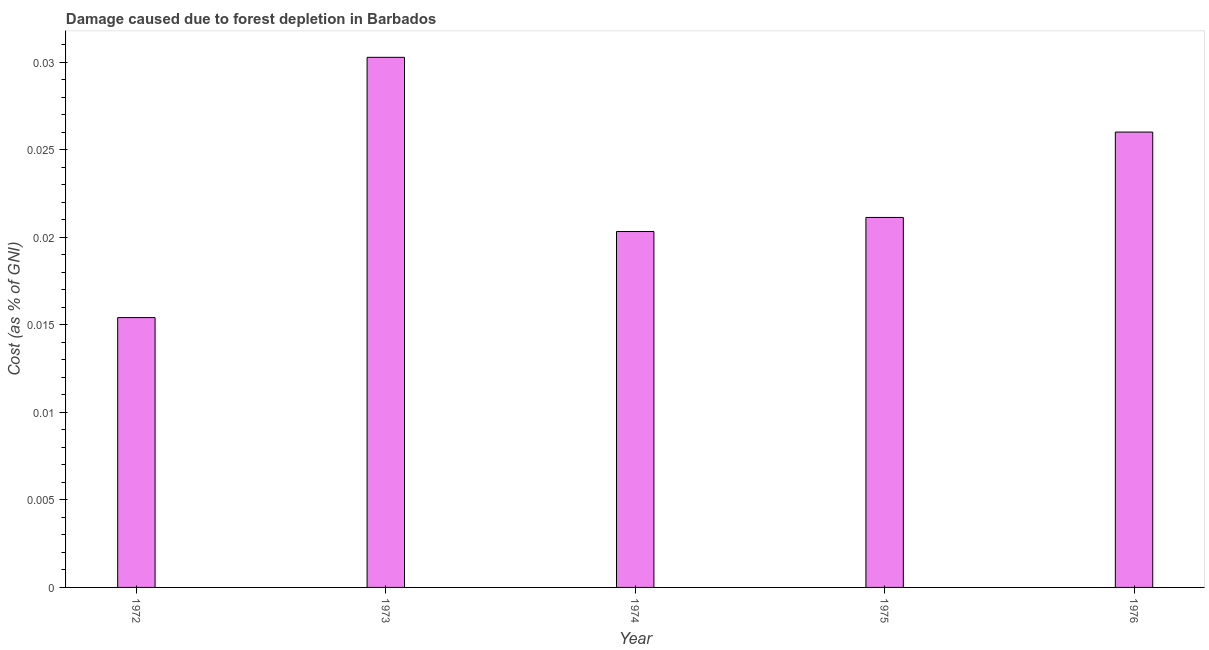Does the graph contain any zero values?
Provide a short and direct response. No. Does the graph contain grids?
Offer a terse response. No. What is the title of the graph?
Your answer should be very brief. Damage caused due to forest depletion in Barbados. What is the label or title of the X-axis?
Your answer should be compact. Year. What is the label or title of the Y-axis?
Provide a short and direct response. Cost (as % of GNI). What is the damage caused due to forest depletion in 1975?
Make the answer very short. 0.02. Across all years, what is the maximum damage caused due to forest depletion?
Provide a succinct answer. 0.03. Across all years, what is the minimum damage caused due to forest depletion?
Offer a terse response. 0.02. In which year was the damage caused due to forest depletion maximum?
Make the answer very short. 1973. What is the sum of the damage caused due to forest depletion?
Keep it short and to the point. 0.11. What is the difference between the damage caused due to forest depletion in 1973 and 1976?
Your answer should be compact. 0. What is the average damage caused due to forest depletion per year?
Your answer should be very brief. 0.02. What is the median damage caused due to forest depletion?
Your response must be concise. 0.02. Do a majority of the years between 1976 and 1973 (inclusive) have damage caused due to forest depletion greater than 0.008 %?
Give a very brief answer. Yes. What is the ratio of the damage caused due to forest depletion in 1973 to that in 1974?
Give a very brief answer. 1.49. Is the difference between the damage caused due to forest depletion in 1972 and 1973 greater than the difference between any two years?
Provide a succinct answer. Yes. What is the difference between the highest and the second highest damage caused due to forest depletion?
Keep it short and to the point. 0. Is the sum of the damage caused due to forest depletion in 1972 and 1974 greater than the maximum damage caused due to forest depletion across all years?
Offer a very short reply. Yes. In how many years, is the damage caused due to forest depletion greater than the average damage caused due to forest depletion taken over all years?
Your answer should be very brief. 2. How many bars are there?
Offer a very short reply. 5. Are all the bars in the graph horizontal?
Provide a succinct answer. No. What is the difference between two consecutive major ticks on the Y-axis?
Your answer should be compact. 0.01. What is the Cost (as % of GNI) of 1972?
Your answer should be very brief. 0.02. What is the Cost (as % of GNI) of 1973?
Your answer should be very brief. 0.03. What is the Cost (as % of GNI) in 1974?
Make the answer very short. 0.02. What is the Cost (as % of GNI) in 1975?
Your response must be concise. 0.02. What is the Cost (as % of GNI) in 1976?
Your response must be concise. 0.03. What is the difference between the Cost (as % of GNI) in 1972 and 1973?
Your answer should be compact. -0.01. What is the difference between the Cost (as % of GNI) in 1972 and 1974?
Your answer should be compact. -0. What is the difference between the Cost (as % of GNI) in 1972 and 1975?
Your answer should be very brief. -0.01. What is the difference between the Cost (as % of GNI) in 1972 and 1976?
Make the answer very short. -0.01. What is the difference between the Cost (as % of GNI) in 1973 and 1974?
Provide a short and direct response. 0.01. What is the difference between the Cost (as % of GNI) in 1973 and 1975?
Give a very brief answer. 0.01. What is the difference between the Cost (as % of GNI) in 1973 and 1976?
Your response must be concise. 0. What is the difference between the Cost (as % of GNI) in 1974 and 1975?
Offer a very short reply. -0. What is the difference between the Cost (as % of GNI) in 1974 and 1976?
Give a very brief answer. -0.01. What is the difference between the Cost (as % of GNI) in 1975 and 1976?
Your answer should be compact. -0. What is the ratio of the Cost (as % of GNI) in 1972 to that in 1973?
Give a very brief answer. 0.51. What is the ratio of the Cost (as % of GNI) in 1972 to that in 1974?
Give a very brief answer. 0.76. What is the ratio of the Cost (as % of GNI) in 1972 to that in 1975?
Your answer should be compact. 0.73. What is the ratio of the Cost (as % of GNI) in 1972 to that in 1976?
Offer a very short reply. 0.59. What is the ratio of the Cost (as % of GNI) in 1973 to that in 1974?
Provide a succinct answer. 1.49. What is the ratio of the Cost (as % of GNI) in 1973 to that in 1975?
Offer a terse response. 1.43. What is the ratio of the Cost (as % of GNI) in 1973 to that in 1976?
Provide a succinct answer. 1.16. What is the ratio of the Cost (as % of GNI) in 1974 to that in 1976?
Offer a very short reply. 0.78. What is the ratio of the Cost (as % of GNI) in 1975 to that in 1976?
Provide a short and direct response. 0.81. 